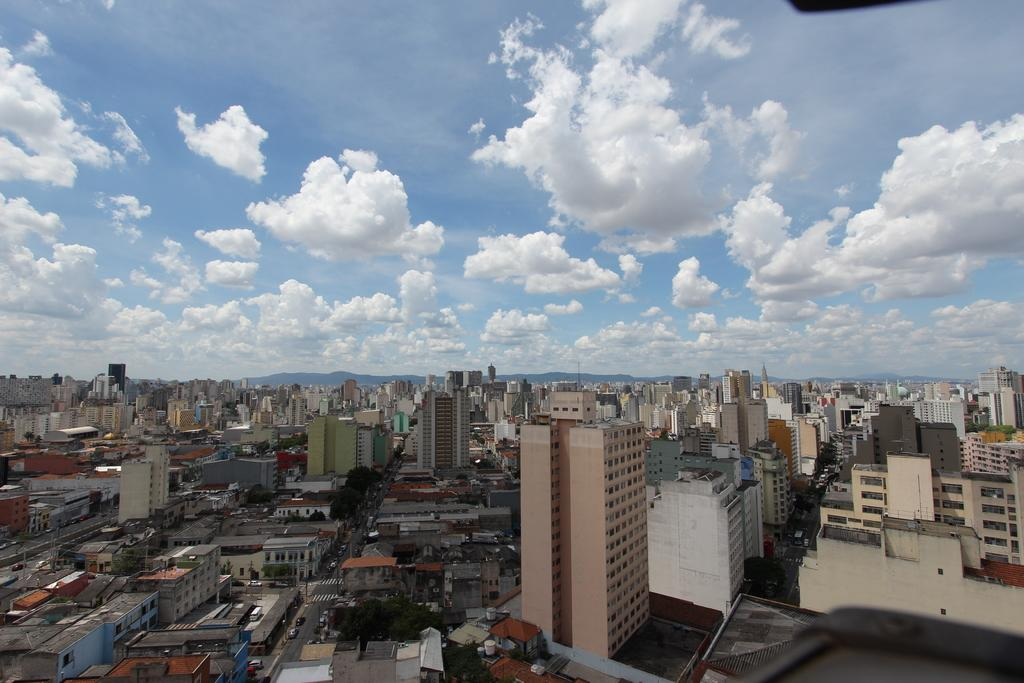What type of structures can be seen in the image? There are buildings in the image. What can be found between the buildings? There are roads in the image. What is moving on the roads? There are vehicles on the roads. What can be seen in the distance behind the buildings? There are hills in the background of the image. What is visible in the sky? The sky is visible in the background of the image, and there are clouds in the sky. What type of judgment is the father making in the image? There is no father or judgment present in the image. How is the judge measuring the distance between the buildings in the image? There is no judge or measuring activity present in the image. 